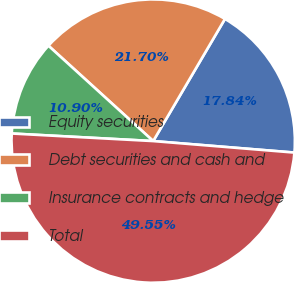<chart> <loc_0><loc_0><loc_500><loc_500><pie_chart><fcel>Equity securities<fcel>Debt securities and cash and<fcel>Insurance contracts and hedge<fcel>Total<nl><fcel>17.84%<fcel>21.7%<fcel>10.9%<fcel>49.55%<nl></chart> 